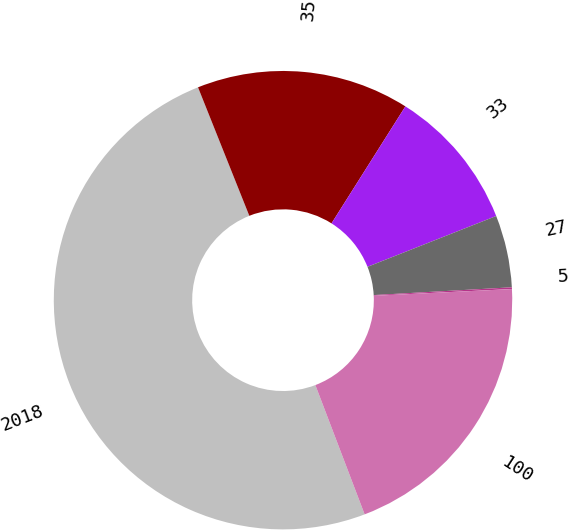Convert chart to OTSL. <chart><loc_0><loc_0><loc_500><loc_500><pie_chart><fcel>2018<fcel>35<fcel>33<fcel>27<fcel>5<fcel>100<nl><fcel>49.75%<fcel>15.01%<fcel>10.05%<fcel>5.09%<fcel>0.12%<fcel>19.98%<nl></chart> 